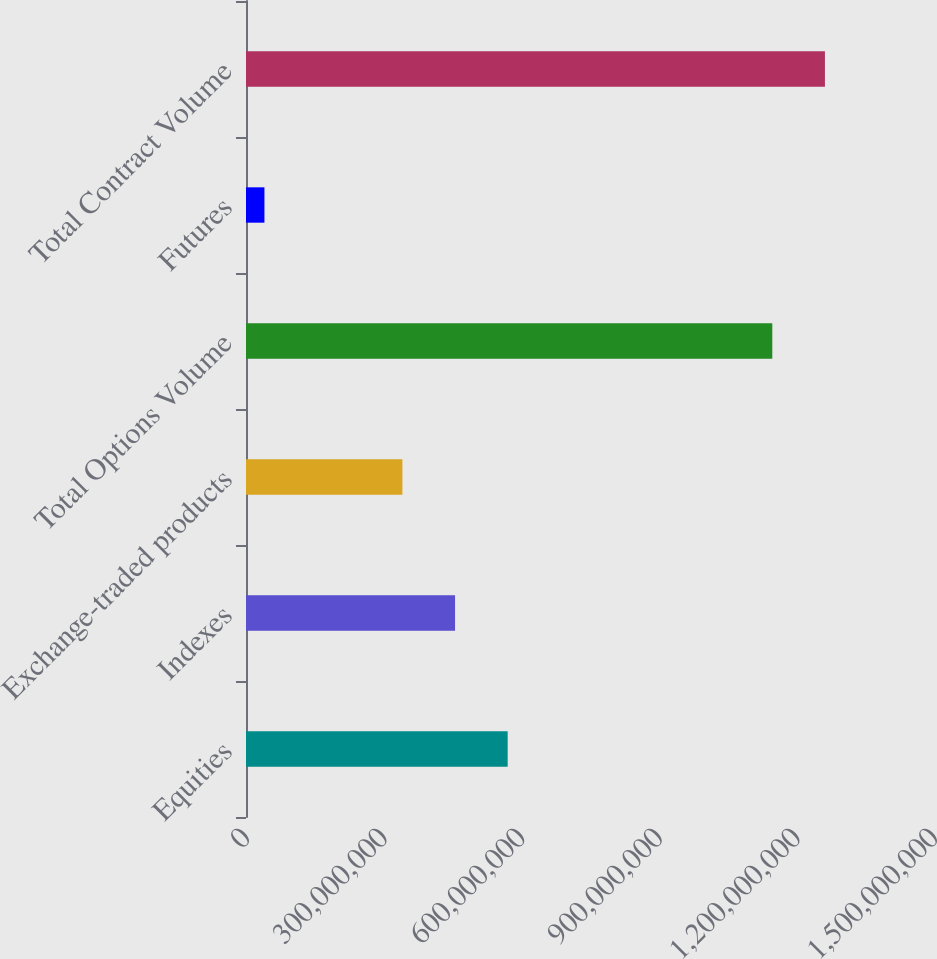Convert chart to OTSL. <chart><loc_0><loc_0><loc_500><loc_500><bar_chart><fcel>Equities<fcel>Indexes<fcel>Exchange-traded products<fcel>Total Options Volume<fcel>Futures<fcel>Total Contract Volume<nl><fcel>5.70513e+08<fcel>4.55768e+08<fcel>3.41023e+08<fcel>1.14745e+09<fcel>4.01934e+07<fcel>1.26219e+09<nl></chart> 